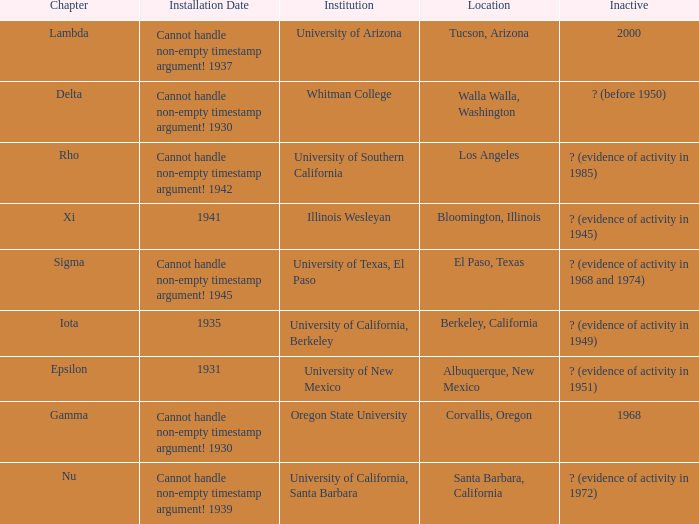Write the full table. {'header': ['Chapter', 'Installation Date', 'Institution', 'Location', 'Inactive'], 'rows': [['Lambda', 'Cannot handle non-empty timestamp argument! 1937', 'University of Arizona', 'Tucson, Arizona', '2000'], ['Delta', 'Cannot handle non-empty timestamp argument! 1930', 'Whitman College', 'Walla Walla, Washington', '? (before 1950)'], ['Rho', 'Cannot handle non-empty timestamp argument! 1942', 'University of Southern California', 'Los Angeles', '? (evidence of activity in 1985)'], ['Xi', '1941', 'Illinois Wesleyan', 'Bloomington, Illinois', '? (evidence of activity in 1945)'], ['Sigma', 'Cannot handle non-empty timestamp argument! 1945', 'University of Texas, El Paso', 'El Paso, Texas', '? (evidence of activity in 1968 and 1974)'], ['Iota', '1935', 'University of California, Berkeley', 'Berkeley, California', '? (evidence of activity in 1949)'], ['Epsilon', '1931', 'University of New Mexico', 'Albuquerque, New Mexico', '? (evidence of activity in 1951)'], ['Gamma', 'Cannot handle non-empty timestamp argument! 1930', 'Oregon State University', 'Corvallis, Oregon', '1968'], ['Nu', 'Cannot handle non-empty timestamp argument! 1939', 'University of California, Santa Barbara', 'Santa Barbara, California', '? (evidence of activity in 1972)']]} What is the chapter for Illinois Wesleyan?  Xi. 